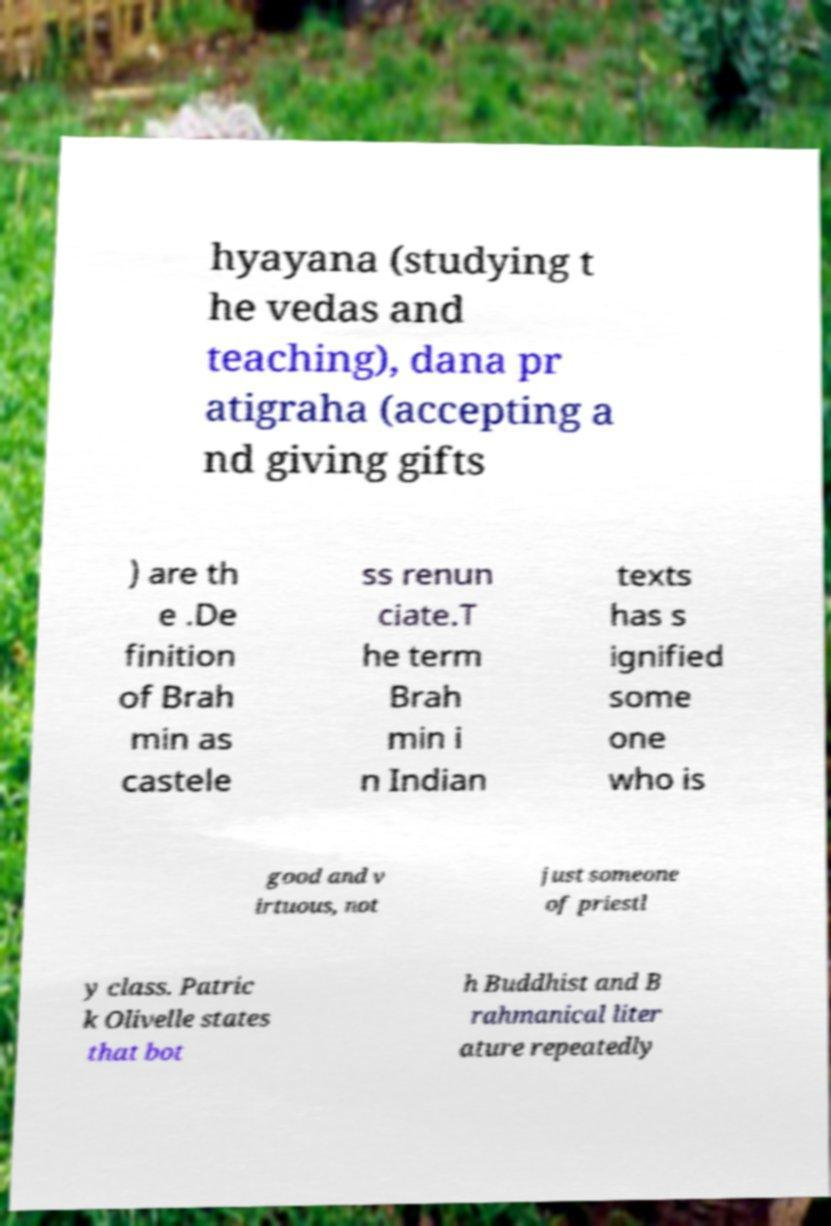Please identify and transcribe the text found in this image. hyayana (studying t he vedas and teaching), dana pr atigraha (accepting a nd giving gifts ) are th e .De finition of Brah min as castele ss renun ciate.T he term Brah min i n Indian texts has s ignified some one who is good and v irtuous, not just someone of priestl y class. Patric k Olivelle states that bot h Buddhist and B rahmanical liter ature repeatedly 